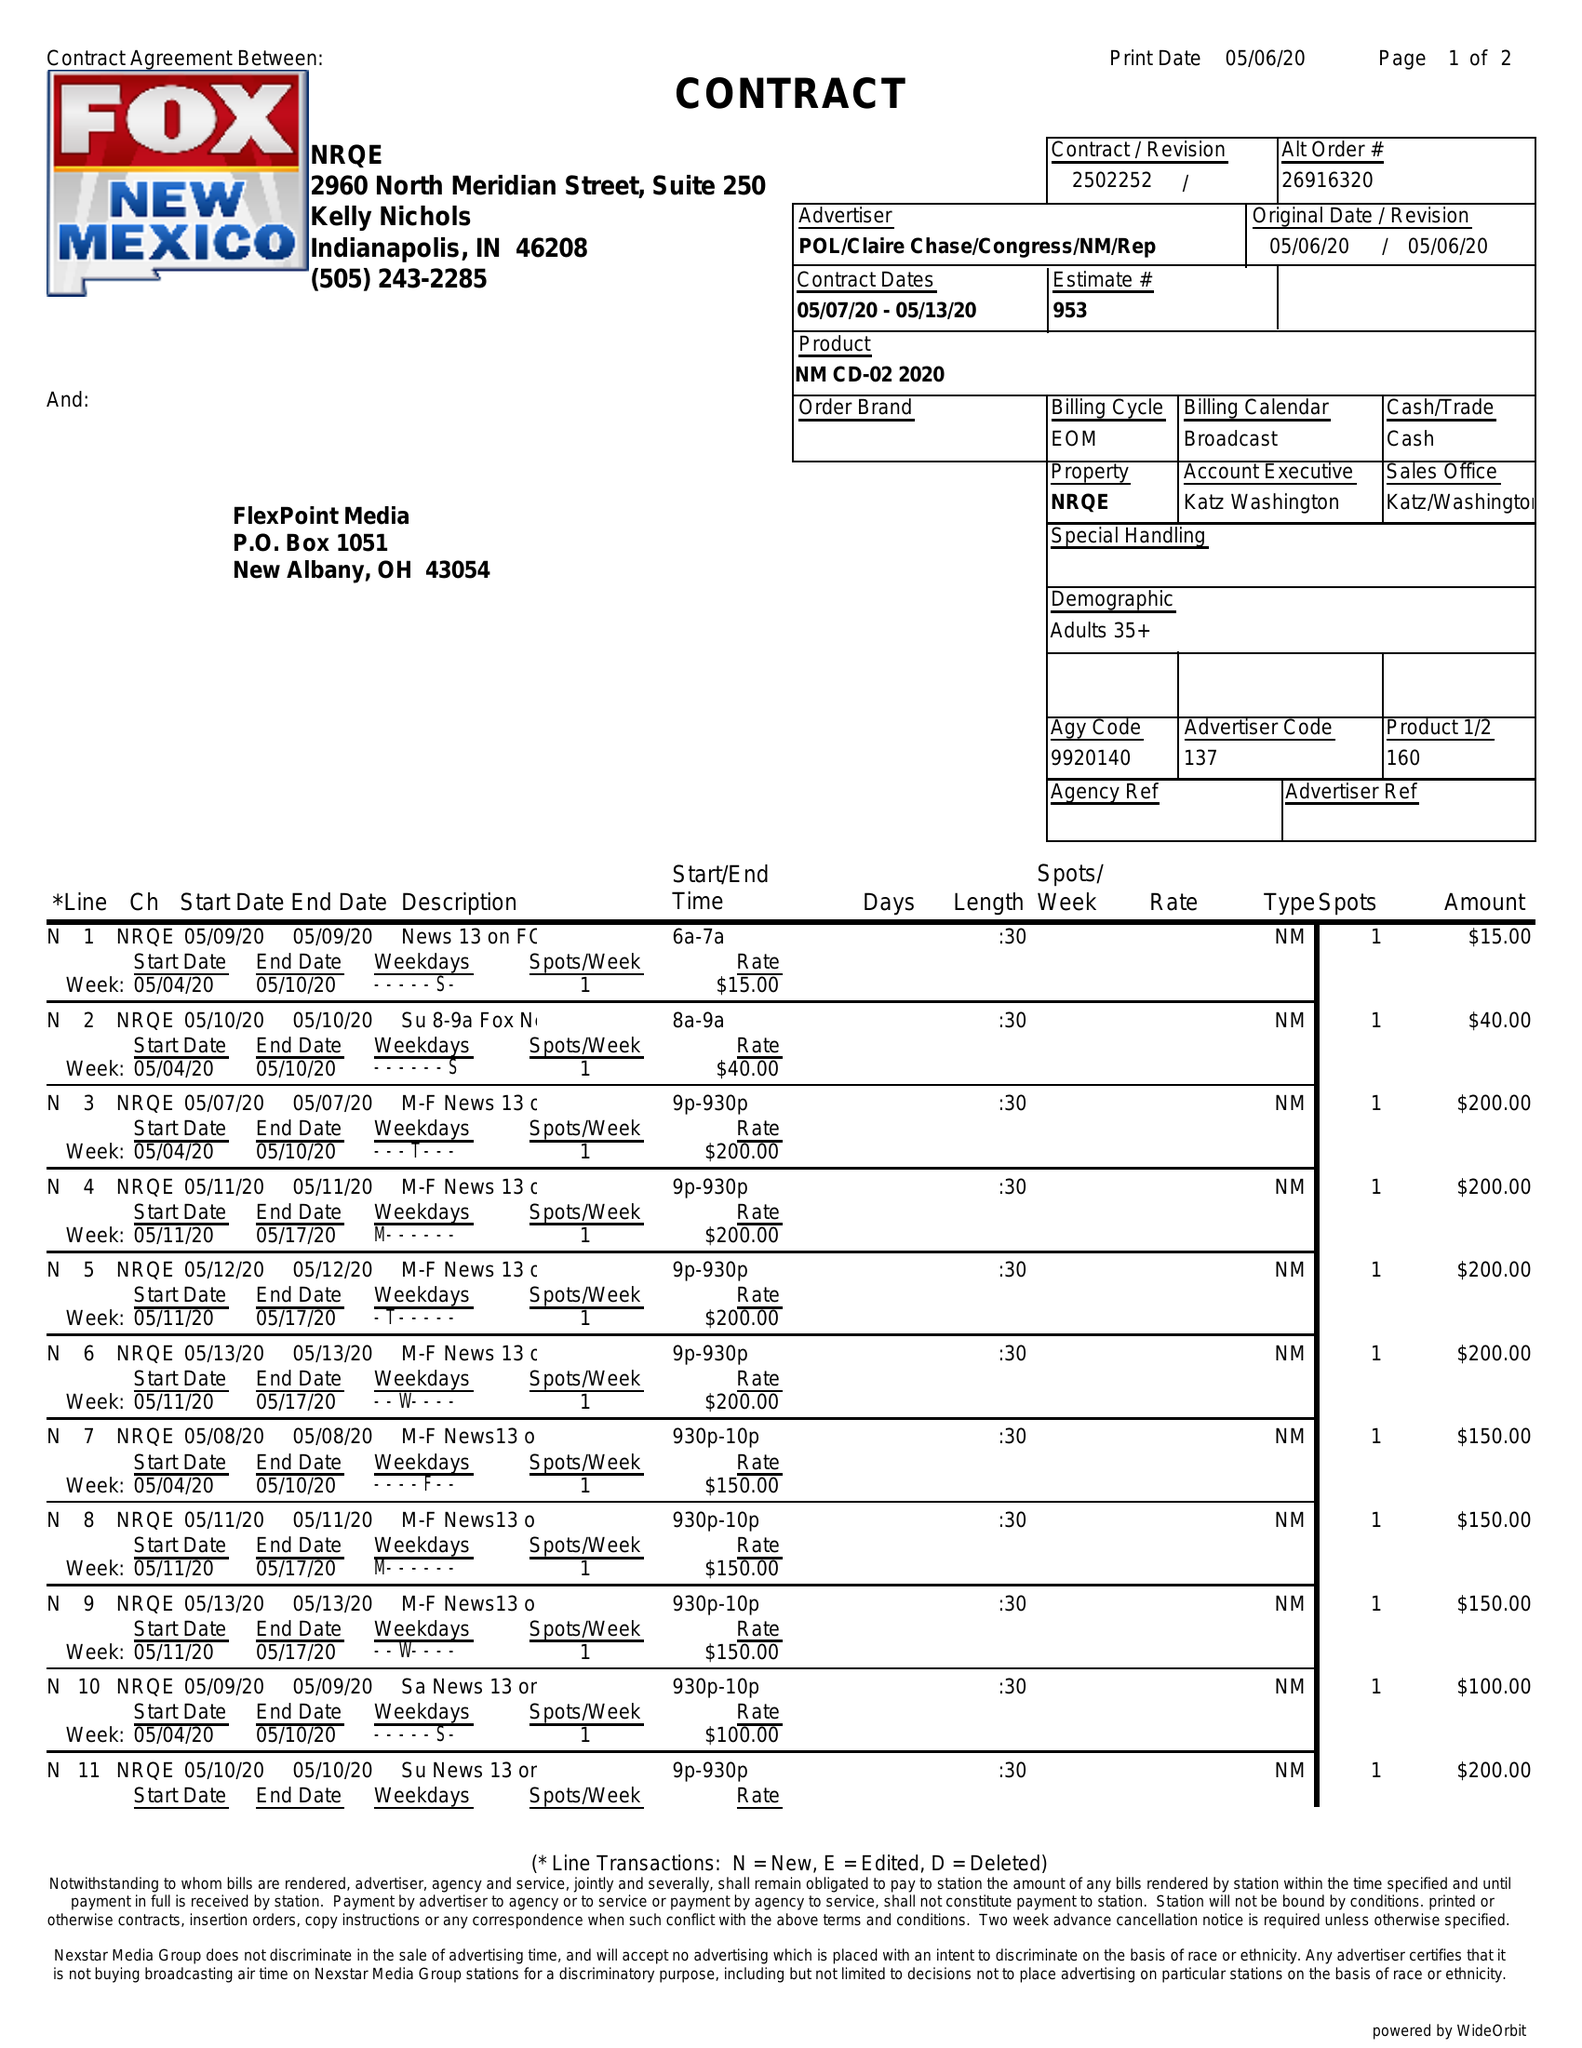What is the value for the flight_to?
Answer the question using a single word or phrase. 05/13/20 